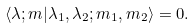<formula> <loc_0><loc_0><loc_500><loc_500>\langle \lambda ; m | \lambda _ { 1 } , \lambda _ { 2 } ; m _ { 1 } , m _ { 2 } \rangle = 0 .</formula> 